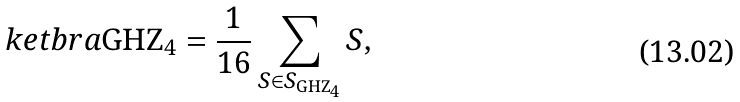Convert formula to latex. <formula><loc_0><loc_0><loc_500><loc_500>\ k e t b r a { \text {GHZ} _ { 4 } } = \frac { 1 } { 1 6 } \sum _ { S \in S _ { \text {GHZ} _ { 4 } } } S ,</formula> 